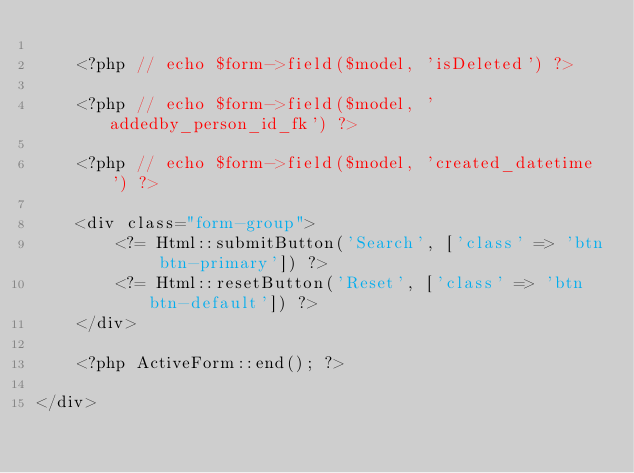<code> <loc_0><loc_0><loc_500><loc_500><_PHP_>
    <?php // echo $form->field($model, 'isDeleted') ?>

    <?php // echo $form->field($model, 'addedby_person_id_fk') ?>

    <?php // echo $form->field($model, 'created_datetime') ?>

    <div class="form-group">
        <?= Html::submitButton('Search', ['class' => 'btn btn-primary']) ?>
        <?= Html::resetButton('Reset', ['class' => 'btn btn-default']) ?>
    </div>

    <?php ActiveForm::end(); ?>

</div>
</code> 